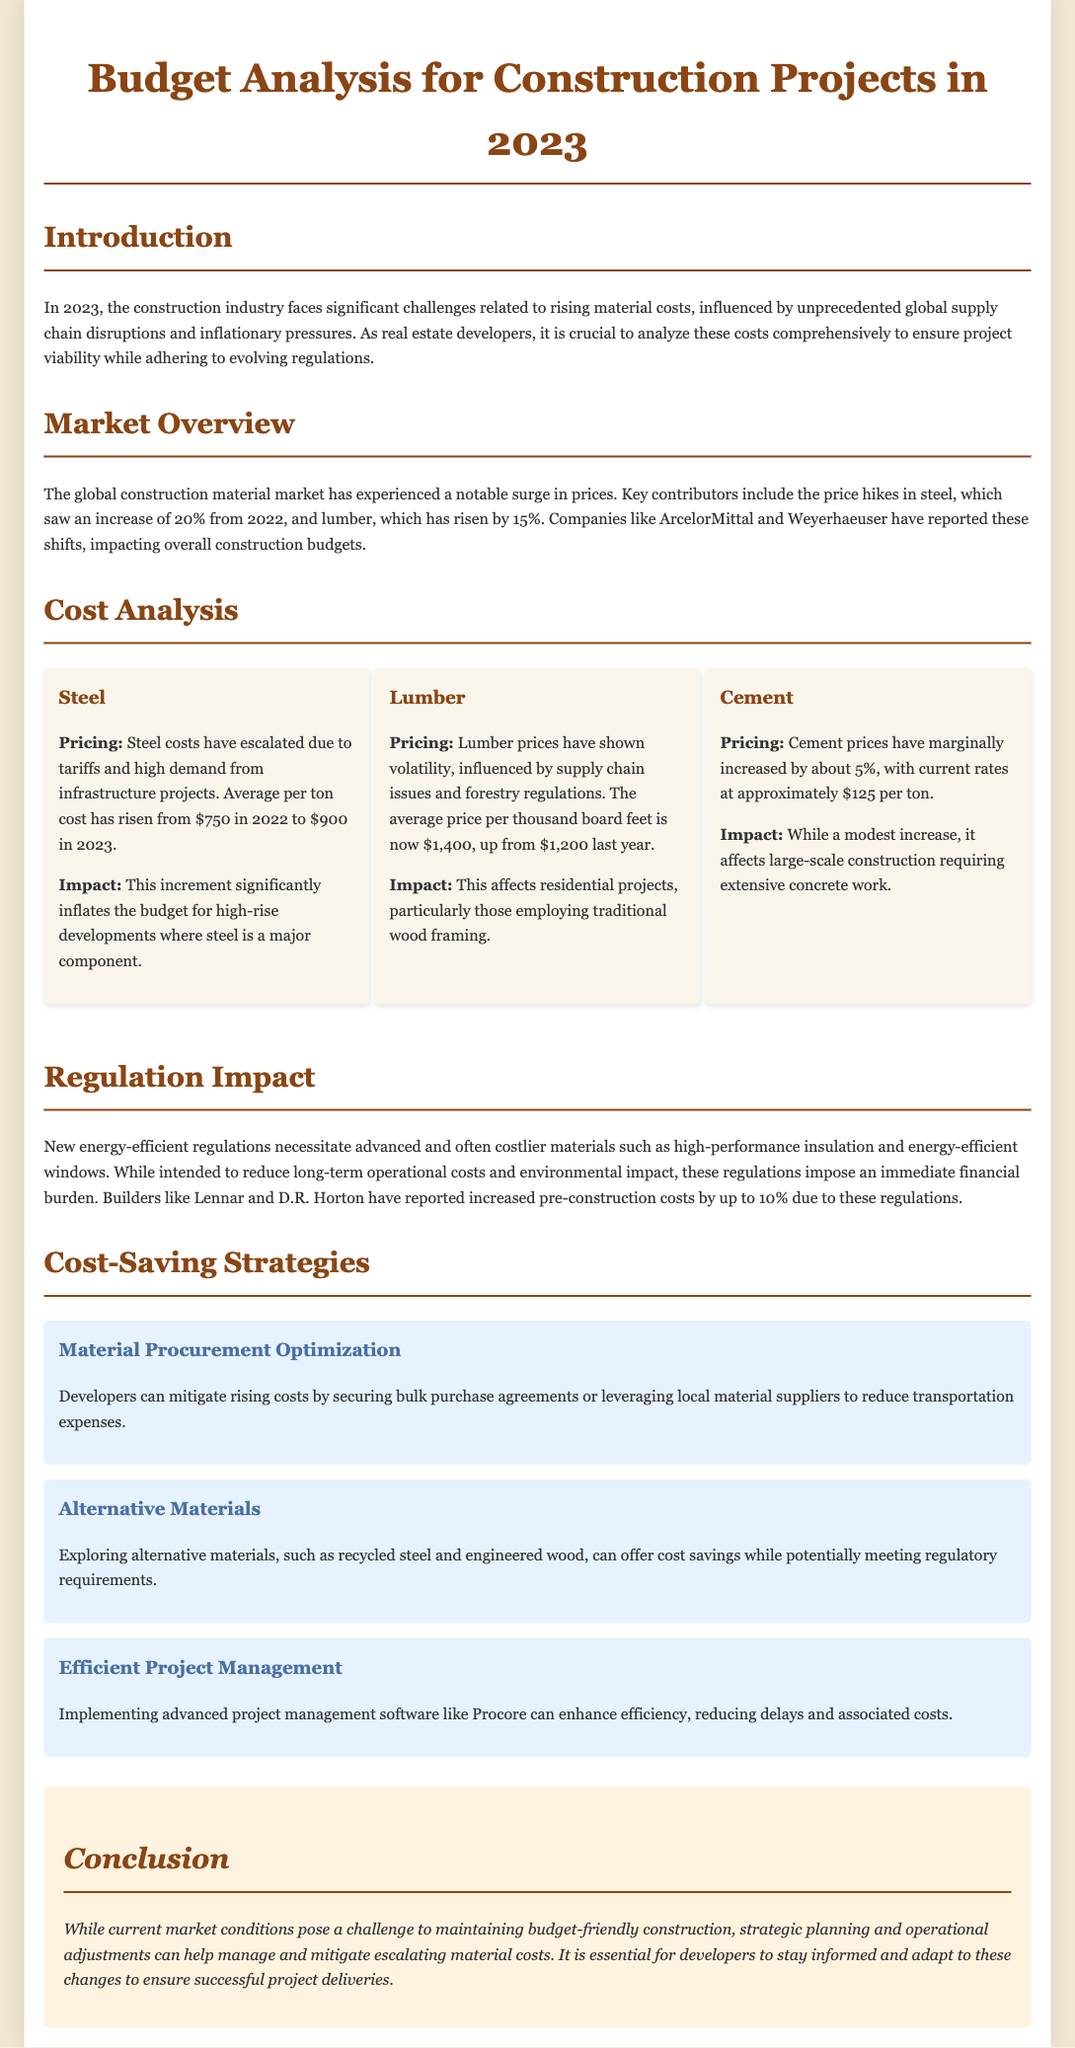What is the title of the document? The title of the document is presented in the header section, which is "Budget Analysis for Construction Projects in 2023."
Answer: Budget Analysis for Construction Projects in 2023 What is the average price of steel in 2023? The document states that the average price per ton of steel has risen to $900 in 2023.
Answer: $900 What percentage increase did lumber prices experience? According to the cost analysis, lumber prices have risen by 15% from the previous year.
Answer: 15% What are two companies mentioned that have reported price increases? The document mentions ArcelorMittal and Weyerhaeuser as companies reporting price changes.
Answer: ArcelorMittal and Weyerhaeuser What is the impact of new energy-efficient regulations on pre-construction costs? Builders like Lennar and D.R. Horton have reported that these regulations have increased pre-construction costs by up to 10%.
Answer: 10% What strategy could developers use to reduce transportation expenses? The document suggests that securing bulk purchase agreements or leveraging local material suppliers could help reduce costs.
Answer: Bulk purchase agreements What was the increase in cement prices in 2023? Cement prices have increased by about 5%, reaching approximately $125 per ton.
Answer: 5% What is one alternative material suggested in the document? The document suggests exploring recycled steel as an alternative material for cost savings.
Answer: Recycled steel 